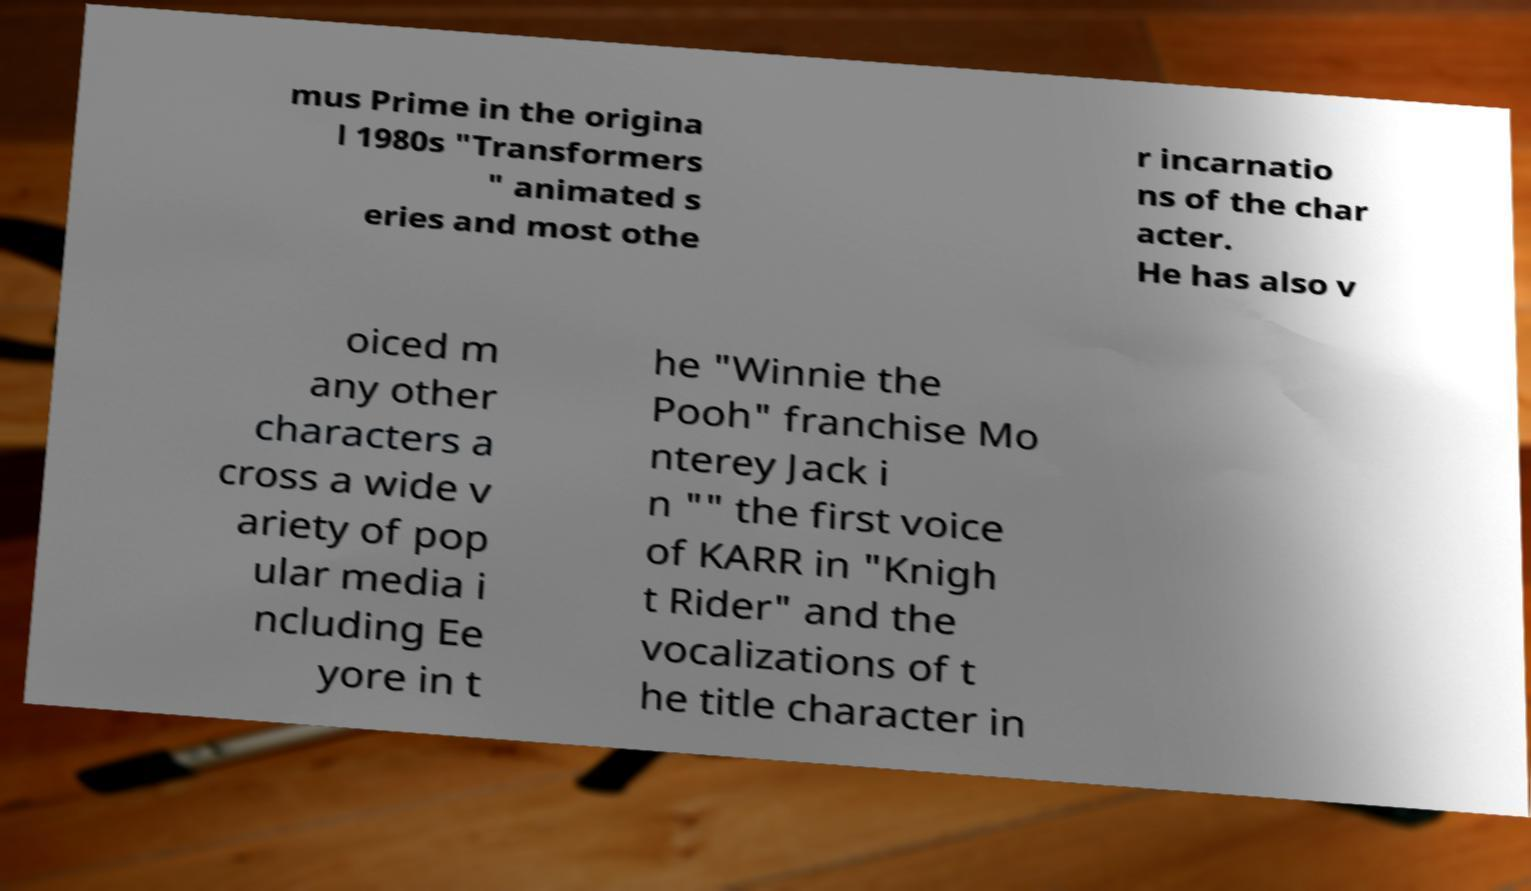I need the written content from this picture converted into text. Can you do that? mus Prime in the origina l 1980s "Transformers " animated s eries and most othe r incarnatio ns of the char acter. He has also v oiced m any other characters a cross a wide v ariety of pop ular media i ncluding Ee yore in t he "Winnie the Pooh" franchise Mo nterey Jack i n "" the first voice of KARR in "Knigh t Rider" and the vocalizations of t he title character in 